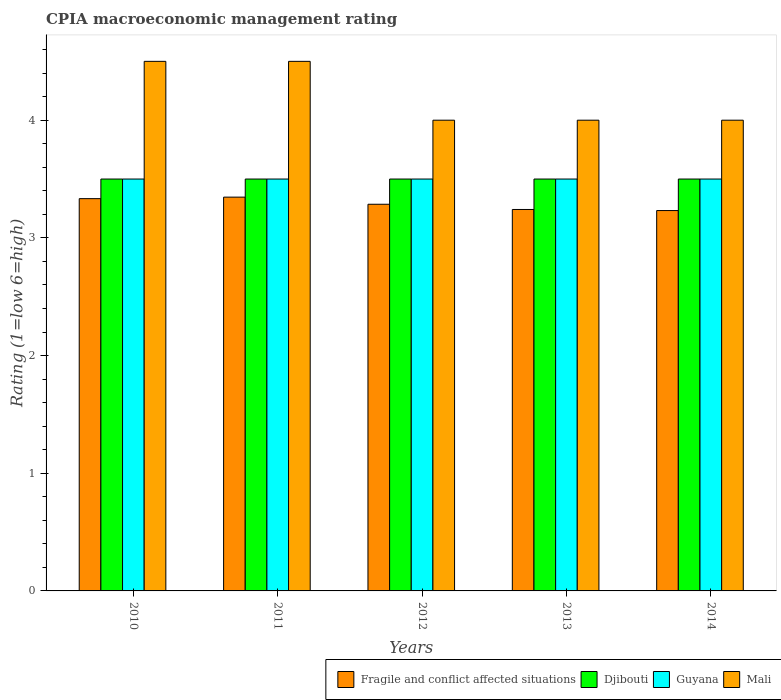How many different coloured bars are there?
Offer a terse response. 4. How many bars are there on the 5th tick from the left?
Provide a short and direct response. 4. How many bars are there on the 1st tick from the right?
Offer a terse response. 4. What is the label of the 5th group of bars from the left?
Your response must be concise. 2014. In how many cases, is the number of bars for a given year not equal to the number of legend labels?
Provide a succinct answer. 0. Across all years, what is the maximum CPIA rating in Fragile and conflict affected situations?
Your response must be concise. 3.35. In which year was the CPIA rating in Djibouti maximum?
Offer a very short reply. 2010. What is the difference between the CPIA rating in Djibouti in 2011 and that in 2013?
Give a very brief answer. 0. What is the difference between the CPIA rating in Djibouti in 2011 and the CPIA rating in Fragile and conflict affected situations in 2012?
Ensure brevity in your answer.  0.21. In how many years, is the CPIA rating in Guyana greater than 4.4?
Your response must be concise. 0. Is the difference between the CPIA rating in Guyana in 2011 and 2012 greater than the difference between the CPIA rating in Mali in 2011 and 2012?
Make the answer very short. No. What is the difference between the highest and the second highest CPIA rating in Guyana?
Ensure brevity in your answer.  0. What is the difference between the highest and the lowest CPIA rating in Mali?
Give a very brief answer. 0.5. Is it the case that in every year, the sum of the CPIA rating in Guyana and CPIA rating in Fragile and conflict affected situations is greater than the sum of CPIA rating in Mali and CPIA rating in Djibouti?
Ensure brevity in your answer.  No. What does the 1st bar from the left in 2013 represents?
Ensure brevity in your answer.  Fragile and conflict affected situations. What does the 1st bar from the right in 2010 represents?
Ensure brevity in your answer.  Mali. Is it the case that in every year, the sum of the CPIA rating in Fragile and conflict affected situations and CPIA rating in Mali is greater than the CPIA rating in Djibouti?
Give a very brief answer. Yes. What is the difference between two consecutive major ticks on the Y-axis?
Provide a succinct answer. 1. Are the values on the major ticks of Y-axis written in scientific E-notation?
Offer a terse response. No. Where does the legend appear in the graph?
Make the answer very short. Bottom right. How many legend labels are there?
Your answer should be compact. 4. How are the legend labels stacked?
Keep it short and to the point. Horizontal. What is the title of the graph?
Make the answer very short. CPIA macroeconomic management rating. Does "Montenegro" appear as one of the legend labels in the graph?
Provide a succinct answer. No. What is the Rating (1=low 6=high) of Fragile and conflict affected situations in 2010?
Give a very brief answer. 3.33. What is the Rating (1=low 6=high) in Djibouti in 2010?
Your response must be concise. 3.5. What is the Rating (1=low 6=high) of Mali in 2010?
Provide a succinct answer. 4.5. What is the Rating (1=low 6=high) in Fragile and conflict affected situations in 2011?
Your answer should be compact. 3.35. What is the Rating (1=low 6=high) of Djibouti in 2011?
Your answer should be very brief. 3.5. What is the Rating (1=low 6=high) in Mali in 2011?
Your answer should be very brief. 4.5. What is the Rating (1=low 6=high) of Fragile and conflict affected situations in 2012?
Your answer should be very brief. 3.29. What is the Rating (1=low 6=high) in Djibouti in 2012?
Ensure brevity in your answer.  3.5. What is the Rating (1=low 6=high) in Fragile and conflict affected situations in 2013?
Keep it short and to the point. 3.24. What is the Rating (1=low 6=high) in Guyana in 2013?
Give a very brief answer. 3.5. What is the Rating (1=low 6=high) of Mali in 2013?
Give a very brief answer. 4. What is the Rating (1=low 6=high) of Fragile and conflict affected situations in 2014?
Provide a short and direct response. 3.23. What is the Rating (1=low 6=high) in Djibouti in 2014?
Your response must be concise. 3.5. Across all years, what is the maximum Rating (1=low 6=high) of Fragile and conflict affected situations?
Your response must be concise. 3.35. Across all years, what is the maximum Rating (1=low 6=high) in Mali?
Make the answer very short. 4.5. Across all years, what is the minimum Rating (1=low 6=high) in Fragile and conflict affected situations?
Provide a short and direct response. 3.23. Across all years, what is the minimum Rating (1=low 6=high) of Djibouti?
Your answer should be very brief. 3.5. Across all years, what is the minimum Rating (1=low 6=high) of Guyana?
Make the answer very short. 3.5. What is the total Rating (1=low 6=high) in Fragile and conflict affected situations in the graph?
Your response must be concise. 16.44. What is the total Rating (1=low 6=high) in Djibouti in the graph?
Your answer should be compact. 17.5. What is the total Rating (1=low 6=high) in Guyana in the graph?
Provide a succinct answer. 17.5. What is the difference between the Rating (1=low 6=high) in Fragile and conflict affected situations in 2010 and that in 2011?
Give a very brief answer. -0.01. What is the difference between the Rating (1=low 6=high) in Djibouti in 2010 and that in 2011?
Offer a very short reply. 0. What is the difference between the Rating (1=low 6=high) of Fragile and conflict affected situations in 2010 and that in 2012?
Provide a succinct answer. 0.05. What is the difference between the Rating (1=low 6=high) in Guyana in 2010 and that in 2012?
Give a very brief answer. 0. What is the difference between the Rating (1=low 6=high) in Mali in 2010 and that in 2012?
Provide a succinct answer. 0.5. What is the difference between the Rating (1=low 6=high) in Fragile and conflict affected situations in 2010 and that in 2013?
Ensure brevity in your answer.  0.09. What is the difference between the Rating (1=low 6=high) of Djibouti in 2010 and that in 2013?
Give a very brief answer. 0. What is the difference between the Rating (1=low 6=high) of Mali in 2010 and that in 2013?
Provide a short and direct response. 0.5. What is the difference between the Rating (1=low 6=high) in Fragile and conflict affected situations in 2010 and that in 2014?
Your answer should be very brief. 0.1. What is the difference between the Rating (1=low 6=high) in Fragile and conflict affected situations in 2011 and that in 2012?
Your answer should be compact. 0.06. What is the difference between the Rating (1=low 6=high) in Djibouti in 2011 and that in 2012?
Offer a very short reply. 0. What is the difference between the Rating (1=low 6=high) in Mali in 2011 and that in 2012?
Ensure brevity in your answer.  0.5. What is the difference between the Rating (1=low 6=high) in Fragile and conflict affected situations in 2011 and that in 2013?
Offer a terse response. 0.1. What is the difference between the Rating (1=low 6=high) of Guyana in 2011 and that in 2013?
Offer a very short reply. 0. What is the difference between the Rating (1=low 6=high) in Mali in 2011 and that in 2013?
Make the answer very short. 0.5. What is the difference between the Rating (1=low 6=high) of Fragile and conflict affected situations in 2011 and that in 2014?
Your response must be concise. 0.11. What is the difference between the Rating (1=low 6=high) in Guyana in 2011 and that in 2014?
Provide a short and direct response. 0. What is the difference between the Rating (1=low 6=high) in Fragile and conflict affected situations in 2012 and that in 2013?
Offer a very short reply. 0.04. What is the difference between the Rating (1=low 6=high) in Mali in 2012 and that in 2013?
Offer a terse response. 0. What is the difference between the Rating (1=low 6=high) in Fragile and conflict affected situations in 2012 and that in 2014?
Give a very brief answer. 0.05. What is the difference between the Rating (1=low 6=high) in Djibouti in 2012 and that in 2014?
Give a very brief answer. 0. What is the difference between the Rating (1=low 6=high) of Guyana in 2012 and that in 2014?
Your answer should be compact. 0. What is the difference between the Rating (1=low 6=high) in Mali in 2012 and that in 2014?
Give a very brief answer. 0. What is the difference between the Rating (1=low 6=high) in Fragile and conflict affected situations in 2013 and that in 2014?
Ensure brevity in your answer.  0.01. What is the difference between the Rating (1=low 6=high) in Mali in 2013 and that in 2014?
Ensure brevity in your answer.  0. What is the difference between the Rating (1=low 6=high) in Fragile and conflict affected situations in 2010 and the Rating (1=low 6=high) in Djibouti in 2011?
Give a very brief answer. -0.17. What is the difference between the Rating (1=low 6=high) of Fragile and conflict affected situations in 2010 and the Rating (1=low 6=high) of Guyana in 2011?
Make the answer very short. -0.17. What is the difference between the Rating (1=low 6=high) of Fragile and conflict affected situations in 2010 and the Rating (1=low 6=high) of Mali in 2011?
Offer a terse response. -1.17. What is the difference between the Rating (1=low 6=high) of Djibouti in 2010 and the Rating (1=low 6=high) of Guyana in 2011?
Provide a succinct answer. 0. What is the difference between the Rating (1=low 6=high) in Djibouti in 2010 and the Rating (1=low 6=high) in Mali in 2011?
Make the answer very short. -1. What is the difference between the Rating (1=low 6=high) in Fragile and conflict affected situations in 2010 and the Rating (1=low 6=high) in Djibouti in 2012?
Your answer should be compact. -0.17. What is the difference between the Rating (1=low 6=high) of Fragile and conflict affected situations in 2010 and the Rating (1=low 6=high) of Mali in 2012?
Provide a short and direct response. -0.67. What is the difference between the Rating (1=low 6=high) of Djibouti in 2010 and the Rating (1=low 6=high) of Guyana in 2012?
Offer a very short reply. 0. What is the difference between the Rating (1=low 6=high) of Djibouti in 2010 and the Rating (1=low 6=high) of Mali in 2012?
Offer a terse response. -0.5. What is the difference between the Rating (1=low 6=high) of Guyana in 2010 and the Rating (1=low 6=high) of Mali in 2012?
Provide a succinct answer. -0.5. What is the difference between the Rating (1=low 6=high) in Fragile and conflict affected situations in 2010 and the Rating (1=low 6=high) in Guyana in 2013?
Your answer should be very brief. -0.17. What is the difference between the Rating (1=low 6=high) in Djibouti in 2010 and the Rating (1=low 6=high) in Guyana in 2013?
Offer a very short reply. 0. What is the difference between the Rating (1=low 6=high) of Fragile and conflict affected situations in 2010 and the Rating (1=low 6=high) of Djibouti in 2014?
Your response must be concise. -0.17. What is the difference between the Rating (1=low 6=high) of Fragile and conflict affected situations in 2010 and the Rating (1=low 6=high) of Mali in 2014?
Keep it short and to the point. -0.67. What is the difference between the Rating (1=low 6=high) of Djibouti in 2010 and the Rating (1=low 6=high) of Guyana in 2014?
Provide a short and direct response. 0. What is the difference between the Rating (1=low 6=high) in Fragile and conflict affected situations in 2011 and the Rating (1=low 6=high) in Djibouti in 2012?
Give a very brief answer. -0.15. What is the difference between the Rating (1=low 6=high) of Fragile and conflict affected situations in 2011 and the Rating (1=low 6=high) of Guyana in 2012?
Provide a short and direct response. -0.15. What is the difference between the Rating (1=low 6=high) in Fragile and conflict affected situations in 2011 and the Rating (1=low 6=high) in Mali in 2012?
Your answer should be very brief. -0.65. What is the difference between the Rating (1=low 6=high) in Djibouti in 2011 and the Rating (1=low 6=high) in Guyana in 2012?
Ensure brevity in your answer.  0. What is the difference between the Rating (1=low 6=high) in Guyana in 2011 and the Rating (1=low 6=high) in Mali in 2012?
Provide a succinct answer. -0.5. What is the difference between the Rating (1=low 6=high) of Fragile and conflict affected situations in 2011 and the Rating (1=low 6=high) of Djibouti in 2013?
Offer a very short reply. -0.15. What is the difference between the Rating (1=low 6=high) of Fragile and conflict affected situations in 2011 and the Rating (1=low 6=high) of Guyana in 2013?
Your answer should be compact. -0.15. What is the difference between the Rating (1=low 6=high) of Fragile and conflict affected situations in 2011 and the Rating (1=low 6=high) of Mali in 2013?
Offer a terse response. -0.65. What is the difference between the Rating (1=low 6=high) of Djibouti in 2011 and the Rating (1=low 6=high) of Mali in 2013?
Provide a succinct answer. -0.5. What is the difference between the Rating (1=low 6=high) in Fragile and conflict affected situations in 2011 and the Rating (1=low 6=high) in Djibouti in 2014?
Keep it short and to the point. -0.15. What is the difference between the Rating (1=low 6=high) in Fragile and conflict affected situations in 2011 and the Rating (1=low 6=high) in Guyana in 2014?
Provide a short and direct response. -0.15. What is the difference between the Rating (1=low 6=high) in Fragile and conflict affected situations in 2011 and the Rating (1=low 6=high) in Mali in 2014?
Make the answer very short. -0.65. What is the difference between the Rating (1=low 6=high) in Djibouti in 2011 and the Rating (1=low 6=high) in Mali in 2014?
Provide a succinct answer. -0.5. What is the difference between the Rating (1=low 6=high) in Guyana in 2011 and the Rating (1=low 6=high) in Mali in 2014?
Give a very brief answer. -0.5. What is the difference between the Rating (1=low 6=high) of Fragile and conflict affected situations in 2012 and the Rating (1=low 6=high) of Djibouti in 2013?
Give a very brief answer. -0.21. What is the difference between the Rating (1=low 6=high) in Fragile and conflict affected situations in 2012 and the Rating (1=low 6=high) in Guyana in 2013?
Ensure brevity in your answer.  -0.21. What is the difference between the Rating (1=low 6=high) in Fragile and conflict affected situations in 2012 and the Rating (1=low 6=high) in Mali in 2013?
Give a very brief answer. -0.71. What is the difference between the Rating (1=low 6=high) in Fragile and conflict affected situations in 2012 and the Rating (1=low 6=high) in Djibouti in 2014?
Provide a succinct answer. -0.21. What is the difference between the Rating (1=low 6=high) of Fragile and conflict affected situations in 2012 and the Rating (1=low 6=high) of Guyana in 2014?
Your response must be concise. -0.21. What is the difference between the Rating (1=low 6=high) in Fragile and conflict affected situations in 2012 and the Rating (1=low 6=high) in Mali in 2014?
Provide a short and direct response. -0.71. What is the difference between the Rating (1=low 6=high) in Djibouti in 2012 and the Rating (1=low 6=high) in Mali in 2014?
Provide a short and direct response. -0.5. What is the difference between the Rating (1=low 6=high) in Fragile and conflict affected situations in 2013 and the Rating (1=low 6=high) in Djibouti in 2014?
Offer a very short reply. -0.26. What is the difference between the Rating (1=low 6=high) of Fragile and conflict affected situations in 2013 and the Rating (1=low 6=high) of Guyana in 2014?
Provide a succinct answer. -0.26. What is the difference between the Rating (1=low 6=high) of Fragile and conflict affected situations in 2013 and the Rating (1=low 6=high) of Mali in 2014?
Keep it short and to the point. -0.76. What is the difference between the Rating (1=low 6=high) of Djibouti in 2013 and the Rating (1=low 6=high) of Guyana in 2014?
Give a very brief answer. 0. What is the difference between the Rating (1=low 6=high) of Djibouti in 2013 and the Rating (1=low 6=high) of Mali in 2014?
Provide a short and direct response. -0.5. What is the average Rating (1=low 6=high) in Fragile and conflict affected situations per year?
Provide a short and direct response. 3.29. What is the average Rating (1=low 6=high) of Djibouti per year?
Ensure brevity in your answer.  3.5. In the year 2010, what is the difference between the Rating (1=low 6=high) of Fragile and conflict affected situations and Rating (1=low 6=high) of Mali?
Keep it short and to the point. -1.17. In the year 2010, what is the difference between the Rating (1=low 6=high) of Djibouti and Rating (1=low 6=high) of Mali?
Keep it short and to the point. -1. In the year 2010, what is the difference between the Rating (1=low 6=high) of Guyana and Rating (1=low 6=high) of Mali?
Your response must be concise. -1. In the year 2011, what is the difference between the Rating (1=low 6=high) of Fragile and conflict affected situations and Rating (1=low 6=high) of Djibouti?
Keep it short and to the point. -0.15. In the year 2011, what is the difference between the Rating (1=low 6=high) in Fragile and conflict affected situations and Rating (1=low 6=high) in Guyana?
Offer a terse response. -0.15. In the year 2011, what is the difference between the Rating (1=low 6=high) in Fragile and conflict affected situations and Rating (1=low 6=high) in Mali?
Offer a very short reply. -1.15. In the year 2011, what is the difference between the Rating (1=low 6=high) in Djibouti and Rating (1=low 6=high) in Guyana?
Offer a terse response. 0. In the year 2011, what is the difference between the Rating (1=low 6=high) of Djibouti and Rating (1=low 6=high) of Mali?
Your answer should be very brief. -1. In the year 2011, what is the difference between the Rating (1=low 6=high) in Guyana and Rating (1=low 6=high) in Mali?
Offer a terse response. -1. In the year 2012, what is the difference between the Rating (1=low 6=high) of Fragile and conflict affected situations and Rating (1=low 6=high) of Djibouti?
Your response must be concise. -0.21. In the year 2012, what is the difference between the Rating (1=low 6=high) in Fragile and conflict affected situations and Rating (1=low 6=high) in Guyana?
Your answer should be compact. -0.21. In the year 2012, what is the difference between the Rating (1=low 6=high) of Fragile and conflict affected situations and Rating (1=low 6=high) of Mali?
Offer a very short reply. -0.71. In the year 2012, what is the difference between the Rating (1=low 6=high) of Djibouti and Rating (1=low 6=high) of Guyana?
Make the answer very short. 0. In the year 2012, what is the difference between the Rating (1=low 6=high) in Djibouti and Rating (1=low 6=high) in Mali?
Ensure brevity in your answer.  -0.5. In the year 2013, what is the difference between the Rating (1=low 6=high) of Fragile and conflict affected situations and Rating (1=low 6=high) of Djibouti?
Your response must be concise. -0.26. In the year 2013, what is the difference between the Rating (1=low 6=high) in Fragile and conflict affected situations and Rating (1=low 6=high) in Guyana?
Provide a succinct answer. -0.26. In the year 2013, what is the difference between the Rating (1=low 6=high) of Fragile and conflict affected situations and Rating (1=low 6=high) of Mali?
Ensure brevity in your answer.  -0.76. In the year 2013, what is the difference between the Rating (1=low 6=high) of Djibouti and Rating (1=low 6=high) of Guyana?
Offer a terse response. 0. In the year 2014, what is the difference between the Rating (1=low 6=high) in Fragile and conflict affected situations and Rating (1=low 6=high) in Djibouti?
Provide a short and direct response. -0.27. In the year 2014, what is the difference between the Rating (1=low 6=high) of Fragile and conflict affected situations and Rating (1=low 6=high) of Guyana?
Offer a terse response. -0.27. In the year 2014, what is the difference between the Rating (1=low 6=high) of Fragile and conflict affected situations and Rating (1=low 6=high) of Mali?
Make the answer very short. -0.77. In the year 2014, what is the difference between the Rating (1=low 6=high) of Djibouti and Rating (1=low 6=high) of Guyana?
Give a very brief answer. 0. In the year 2014, what is the difference between the Rating (1=low 6=high) of Guyana and Rating (1=low 6=high) of Mali?
Offer a terse response. -0.5. What is the ratio of the Rating (1=low 6=high) in Fragile and conflict affected situations in 2010 to that in 2011?
Your answer should be compact. 1. What is the ratio of the Rating (1=low 6=high) of Djibouti in 2010 to that in 2011?
Your answer should be very brief. 1. What is the ratio of the Rating (1=low 6=high) of Fragile and conflict affected situations in 2010 to that in 2012?
Provide a short and direct response. 1.01. What is the ratio of the Rating (1=low 6=high) in Djibouti in 2010 to that in 2012?
Make the answer very short. 1. What is the ratio of the Rating (1=low 6=high) of Fragile and conflict affected situations in 2010 to that in 2013?
Your answer should be compact. 1.03. What is the ratio of the Rating (1=low 6=high) of Djibouti in 2010 to that in 2013?
Make the answer very short. 1. What is the ratio of the Rating (1=low 6=high) in Guyana in 2010 to that in 2013?
Your answer should be compact. 1. What is the ratio of the Rating (1=low 6=high) of Mali in 2010 to that in 2013?
Your response must be concise. 1.12. What is the ratio of the Rating (1=low 6=high) of Fragile and conflict affected situations in 2010 to that in 2014?
Make the answer very short. 1.03. What is the ratio of the Rating (1=low 6=high) of Djibouti in 2010 to that in 2014?
Make the answer very short. 1. What is the ratio of the Rating (1=low 6=high) of Guyana in 2010 to that in 2014?
Give a very brief answer. 1. What is the ratio of the Rating (1=low 6=high) of Fragile and conflict affected situations in 2011 to that in 2012?
Keep it short and to the point. 1.02. What is the ratio of the Rating (1=low 6=high) in Fragile and conflict affected situations in 2011 to that in 2013?
Your answer should be very brief. 1.03. What is the ratio of the Rating (1=low 6=high) of Djibouti in 2011 to that in 2013?
Provide a succinct answer. 1. What is the ratio of the Rating (1=low 6=high) in Guyana in 2011 to that in 2013?
Offer a terse response. 1. What is the ratio of the Rating (1=low 6=high) of Fragile and conflict affected situations in 2011 to that in 2014?
Ensure brevity in your answer.  1.04. What is the ratio of the Rating (1=low 6=high) in Mali in 2011 to that in 2014?
Your answer should be very brief. 1.12. What is the ratio of the Rating (1=low 6=high) of Fragile and conflict affected situations in 2012 to that in 2013?
Provide a short and direct response. 1.01. What is the ratio of the Rating (1=low 6=high) in Guyana in 2012 to that in 2013?
Offer a very short reply. 1. What is the ratio of the Rating (1=low 6=high) in Fragile and conflict affected situations in 2012 to that in 2014?
Your response must be concise. 1.02. What is the ratio of the Rating (1=low 6=high) of Mali in 2012 to that in 2014?
Your answer should be very brief. 1. What is the ratio of the Rating (1=low 6=high) of Fragile and conflict affected situations in 2013 to that in 2014?
Your answer should be very brief. 1. What is the ratio of the Rating (1=low 6=high) in Mali in 2013 to that in 2014?
Offer a very short reply. 1. What is the difference between the highest and the second highest Rating (1=low 6=high) of Fragile and conflict affected situations?
Offer a very short reply. 0.01. What is the difference between the highest and the second highest Rating (1=low 6=high) of Djibouti?
Offer a terse response. 0. What is the difference between the highest and the second highest Rating (1=low 6=high) of Mali?
Provide a succinct answer. 0. What is the difference between the highest and the lowest Rating (1=low 6=high) in Fragile and conflict affected situations?
Give a very brief answer. 0.11. What is the difference between the highest and the lowest Rating (1=low 6=high) in Guyana?
Ensure brevity in your answer.  0. What is the difference between the highest and the lowest Rating (1=low 6=high) of Mali?
Your answer should be compact. 0.5. 